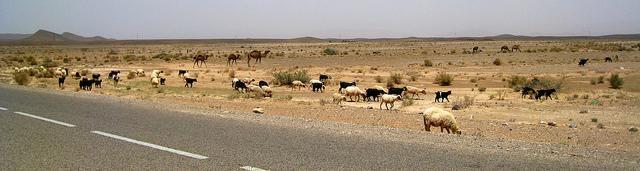How many red kites are there?
Give a very brief answer. 0. 